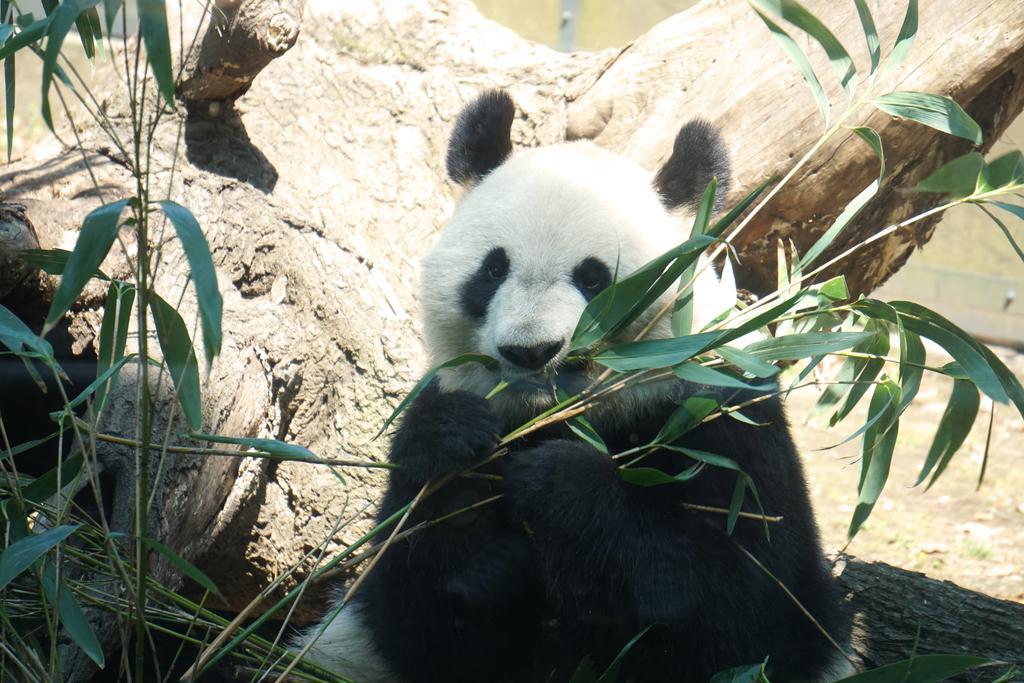Can you describe this image briefly? In the picture we can see a panda sitting on the tree and near the tree we can see some plants with long leaves. 